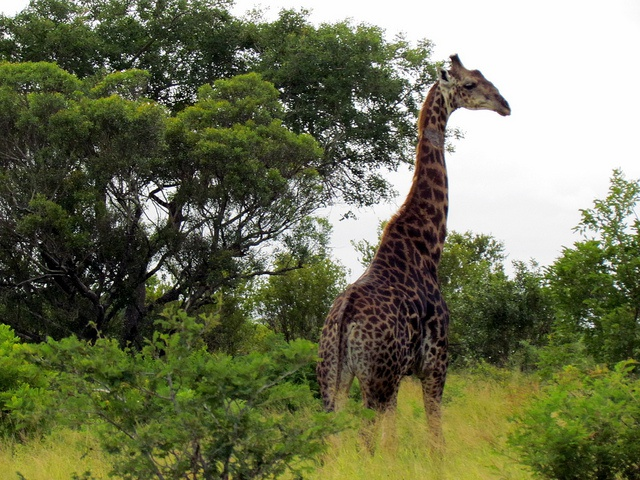Describe the objects in this image and their specific colors. I can see a giraffe in white, black, gray, and maroon tones in this image. 